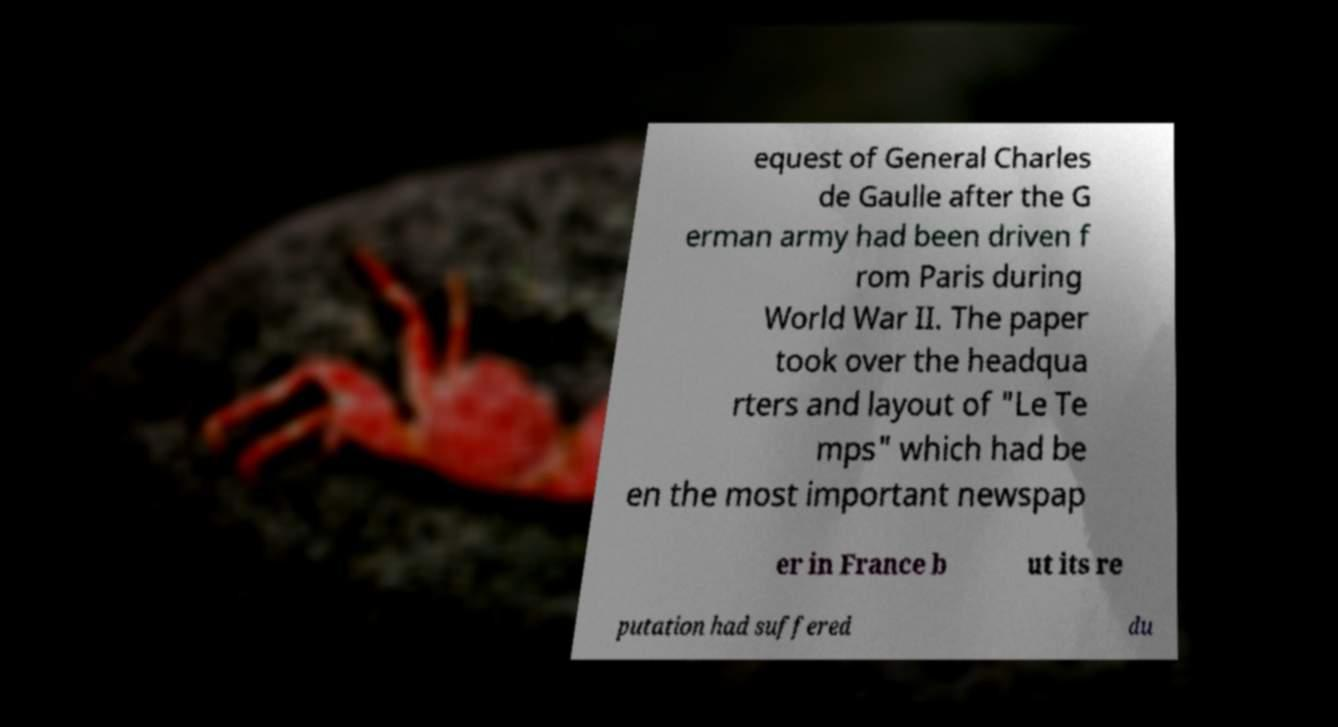Please read and relay the text visible in this image. What does it say? equest of General Charles de Gaulle after the G erman army had been driven f rom Paris during World War II. The paper took over the headqua rters and layout of "Le Te mps" which had be en the most important newspap er in France b ut its re putation had suffered du 